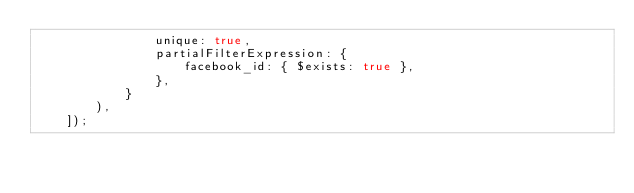Convert code to text. <code><loc_0><loc_0><loc_500><loc_500><_JavaScript_>                unique: true,
                partialFilterExpression: {
                    facebook_id: { $exists: true },
                },
            }
        ),
    ]);
</code> 